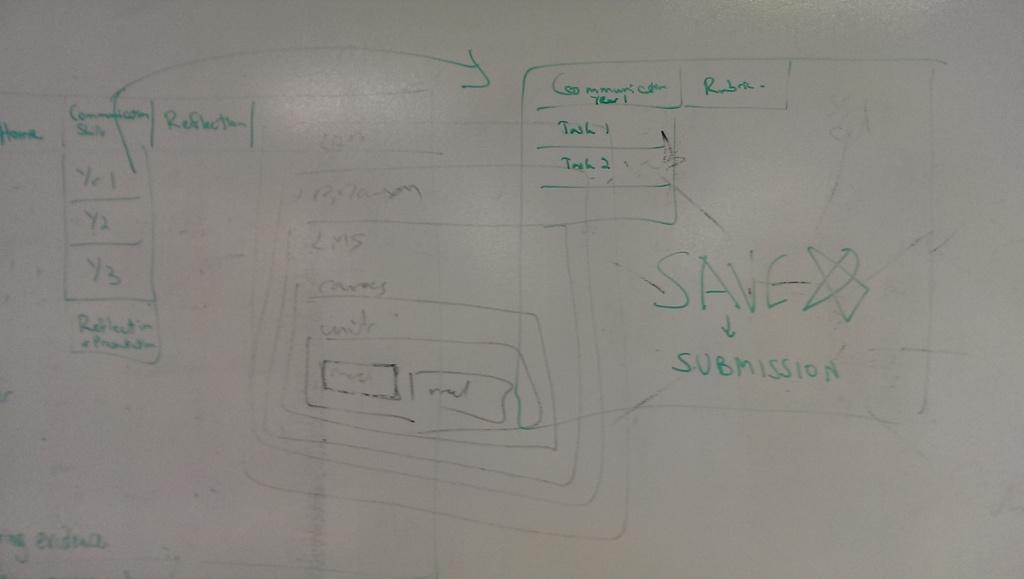What word is written under 'save'?
Offer a very short reply. Submission. What word is given a star?
Offer a very short reply. Save. 